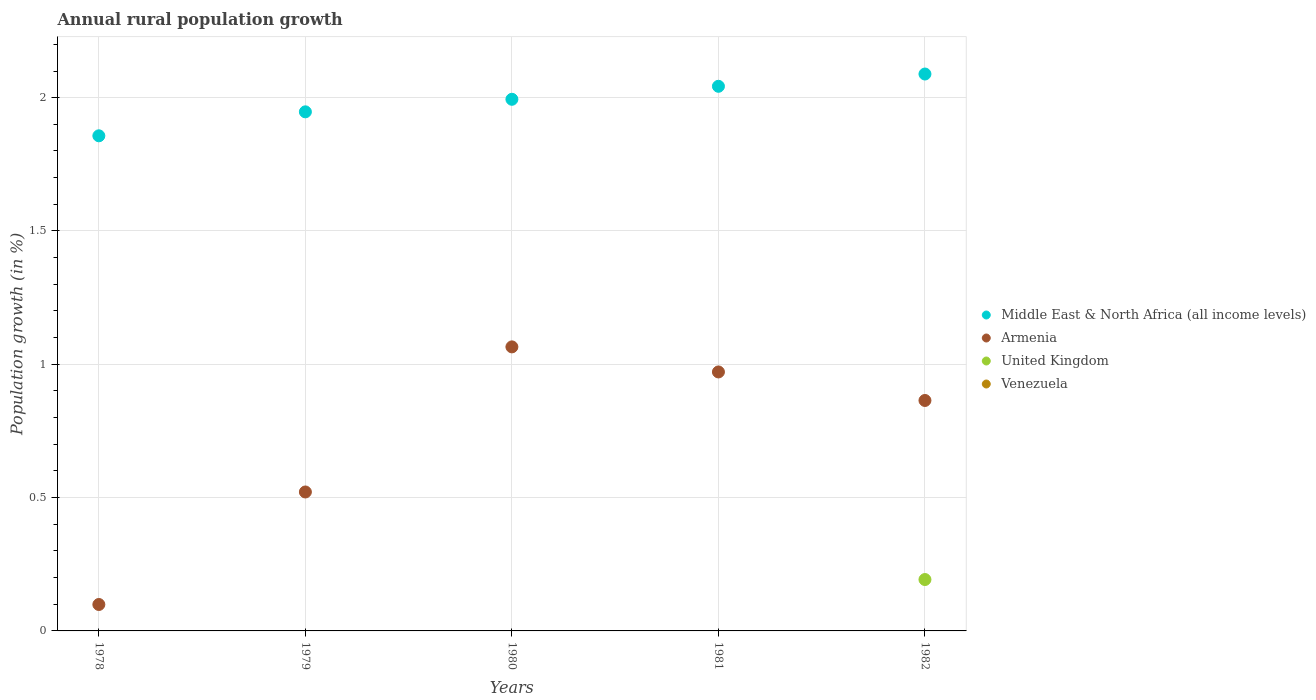How many different coloured dotlines are there?
Your answer should be compact. 3. Is the number of dotlines equal to the number of legend labels?
Provide a succinct answer. No. What is the percentage of rural population growth in United Kingdom in 1978?
Your response must be concise. 0. Across all years, what is the maximum percentage of rural population growth in United Kingdom?
Ensure brevity in your answer.  0.19. Across all years, what is the minimum percentage of rural population growth in Armenia?
Offer a very short reply. 0.1. In which year was the percentage of rural population growth in Armenia maximum?
Provide a short and direct response. 1980. What is the total percentage of rural population growth in Middle East & North Africa (all income levels) in the graph?
Offer a terse response. 9.93. What is the difference between the percentage of rural population growth in Middle East & North Africa (all income levels) in 1978 and that in 1982?
Your answer should be compact. -0.23. What is the difference between the percentage of rural population growth in Middle East & North Africa (all income levels) in 1979 and the percentage of rural population growth in United Kingdom in 1980?
Offer a very short reply. 1.95. What is the average percentage of rural population growth in Middle East & North Africa (all income levels) per year?
Your answer should be compact. 1.99. In the year 1979, what is the difference between the percentage of rural population growth in Middle East & North Africa (all income levels) and percentage of rural population growth in Armenia?
Ensure brevity in your answer.  1.43. What is the ratio of the percentage of rural population growth in Middle East & North Africa (all income levels) in 1980 to that in 1981?
Your answer should be very brief. 0.98. Is the percentage of rural population growth in Middle East & North Africa (all income levels) in 1978 less than that in 1982?
Offer a terse response. Yes. Is the difference between the percentage of rural population growth in Middle East & North Africa (all income levels) in 1979 and 1981 greater than the difference between the percentage of rural population growth in Armenia in 1979 and 1981?
Your response must be concise. Yes. What is the difference between the highest and the second highest percentage of rural population growth in Middle East & North Africa (all income levels)?
Provide a short and direct response. 0.05. Is the sum of the percentage of rural population growth in Armenia in 1978 and 1979 greater than the maximum percentage of rural population growth in Middle East & North Africa (all income levels) across all years?
Offer a very short reply. No. Is it the case that in every year, the sum of the percentage of rural population growth in Venezuela and percentage of rural population growth in Middle East & North Africa (all income levels)  is greater than the percentage of rural population growth in United Kingdom?
Keep it short and to the point. Yes. Does the percentage of rural population growth in Middle East & North Africa (all income levels) monotonically increase over the years?
Make the answer very short. Yes. Is the percentage of rural population growth in Armenia strictly greater than the percentage of rural population growth in Middle East & North Africa (all income levels) over the years?
Your response must be concise. No. Is the percentage of rural population growth in Middle East & North Africa (all income levels) strictly less than the percentage of rural population growth in Venezuela over the years?
Offer a terse response. No. Does the graph contain grids?
Give a very brief answer. Yes. Where does the legend appear in the graph?
Your answer should be very brief. Center right. How are the legend labels stacked?
Your answer should be compact. Vertical. What is the title of the graph?
Ensure brevity in your answer.  Annual rural population growth. Does "Iran" appear as one of the legend labels in the graph?
Provide a succinct answer. No. What is the label or title of the X-axis?
Give a very brief answer. Years. What is the label or title of the Y-axis?
Offer a terse response. Population growth (in %). What is the Population growth (in %) in Middle East & North Africa (all income levels) in 1978?
Keep it short and to the point. 1.86. What is the Population growth (in %) in Armenia in 1978?
Provide a short and direct response. 0.1. What is the Population growth (in %) in United Kingdom in 1978?
Make the answer very short. 0. What is the Population growth (in %) in Venezuela in 1978?
Your response must be concise. 0. What is the Population growth (in %) of Middle East & North Africa (all income levels) in 1979?
Ensure brevity in your answer.  1.95. What is the Population growth (in %) in Armenia in 1979?
Provide a succinct answer. 0.52. What is the Population growth (in %) in United Kingdom in 1979?
Ensure brevity in your answer.  0. What is the Population growth (in %) of Venezuela in 1979?
Ensure brevity in your answer.  0. What is the Population growth (in %) of Middle East & North Africa (all income levels) in 1980?
Provide a succinct answer. 1.99. What is the Population growth (in %) in Armenia in 1980?
Offer a very short reply. 1.07. What is the Population growth (in %) of Middle East & North Africa (all income levels) in 1981?
Provide a succinct answer. 2.04. What is the Population growth (in %) of Armenia in 1981?
Your answer should be compact. 0.97. What is the Population growth (in %) of United Kingdom in 1981?
Your answer should be very brief. 0. What is the Population growth (in %) in Venezuela in 1981?
Your answer should be compact. 0. What is the Population growth (in %) of Middle East & North Africa (all income levels) in 1982?
Provide a short and direct response. 2.09. What is the Population growth (in %) in Armenia in 1982?
Your answer should be compact. 0.86. What is the Population growth (in %) in United Kingdom in 1982?
Give a very brief answer. 0.19. What is the Population growth (in %) in Venezuela in 1982?
Keep it short and to the point. 0. Across all years, what is the maximum Population growth (in %) of Middle East & North Africa (all income levels)?
Offer a very short reply. 2.09. Across all years, what is the maximum Population growth (in %) of Armenia?
Give a very brief answer. 1.07. Across all years, what is the maximum Population growth (in %) of United Kingdom?
Your response must be concise. 0.19. Across all years, what is the minimum Population growth (in %) in Middle East & North Africa (all income levels)?
Your answer should be compact. 1.86. Across all years, what is the minimum Population growth (in %) of Armenia?
Your answer should be compact. 0.1. What is the total Population growth (in %) of Middle East & North Africa (all income levels) in the graph?
Your answer should be very brief. 9.93. What is the total Population growth (in %) in Armenia in the graph?
Your answer should be compact. 3.52. What is the total Population growth (in %) in United Kingdom in the graph?
Offer a very short reply. 0.19. What is the total Population growth (in %) in Venezuela in the graph?
Make the answer very short. 0. What is the difference between the Population growth (in %) in Middle East & North Africa (all income levels) in 1978 and that in 1979?
Offer a very short reply. -0.09. What is the difference between the Population growth (in %) in Armenia in 1978 and that in 1979?
Your answer should be compact. -0.42. What is the difference between the Population growth (in %) of Middle East & North Africa (all income levels) in 1978 and that in 1980?
Ensure brevity in your answer.  -0.14. What is the difference between the Population growth (in %) of Armenia in 1978 and that in 1980?
Your answer should be compact. -0.97. What is the difference between the Population growth (in %) in Middle East & North Africa (all income levels) in 1978 and that in 1981?
Provide a short and direct response. -0.19. What is the difference between the Population growth (in %) of Armenia in 1978 and that in 1981?
Ensure brevity in your answer.  -0.87. What is the difference between the Population growth (in %) in Middle East & North Africa (all income levels) in 1978 and that in 1982?
Offer a very short reply. -0.23. What is the difference between the Population growth (in %) in Armenia in 1978 and that in 1982?
Provide a succinct answer. -0.77. What is the difference between the Population growth (in %) of Middle East & North Africa (all income levels) in 1979 and that in 1980?
Make the answer very short. -0.05. What is the difference between the Population growth (in %) in Armenia in 1979 and that in 1980?
Keep it short and to the point. -0.54. What is the difference between the Population growth (in %) of Middle East & North Africa (all income levels) in 1979 and that in 1981?
Ensure brevity in your answer.  -0.1. What is the difference between the Population growth (in %) in Armenia in 1979 and that in 1981?
Ensure brevity in your answer.  -0.45. What is the difference between the Population growth (in %) in Middle East & North Africa (all income levels) in 1979 and that in 1982?
Ensure brevity in your answer.  -0.14. What is the difference between the Population growth (in %) in Armenia in 1979 and that in 1982?
Your answer should be compact. -0.34. What is the difference between the Population growth (in %) of Middle East & North Africa (all income levels) in 1980 and that in 1981?
Give a very brief answer. -0.05. What is the difference between the Population growth (in %) of Armenia in 1980 and that in 1981?
Your answer should be compact. 0.09. What is the difference between the Population growth (in %) of Middle East & North Africa (all income levels) in 1980 and that in 1982?
Provide a short and direct response. -0.09. What is the difference between the Population growth (in %) of Armenia in 1980 and that in 1982?
Your answer should be compact. 0.2. What is the difference between the Population growth (in %) of Middle East & North Africa (all income levels) in 1981 and that in 1982?
Provide a succinct answer. -0.05. What is the difference between the Population growth (in %) of Armenia in 1981 and that in 1982?
Provide a short and direct response. 0.11. What is the difference between the Population growth (in %) in Middle East & North Africa (all income levels) in 1978 and the Population growth (in %) in Armenia in 1979?
Your response must be concise. 1.34. What is the difference between the Population growth (in %) of Middle East & North Africa (all income levels) in 1978 and the Population growth (in %) of Armenia in 1980?
Offer a very short reply. 0.79. What is the difference between the Population growth (in %) in Middle East & North Africa (all income levels) in 1978 and the Population growth (in %) in Armenia in 1981?
Your answer should be very brief. 0.89. What is the difference between the Population growth (in %) of Middle East & North Africa (all income levels) in 1978 and the Population growth (in %) of Armenia in 1982?
Offer a very short reply. 0.99. What is the difference between the Population growth (in %) of Middle East & North Africa (all income levels) in 1978 and the Population growth (in %) of United Kingdom in 1982?
Offer a terse response. 1.66. What is the difference between the Population growth (in %) of Armenia in 1978 and the Population growth (in %) of United Kingdom in 1982?
Keep it short and to the point. -0.09. What is the difference between the Population growth (in %) of Middle East & North Africa (all income levels) in 1979 and the Population growth (in %) of Armenia in 1980?
Provide a short and direct response. 0.88. What is the difference between the Population growth (in %) of Middle East & North Africa (all income levels) in 1979 and the Population growth (in %) of Armenia in 1981?
Offer a very short reply. 0.98. What is the difference between the Population growth (in %) in Middle East & North Africa (all income levels) in 1979 and the Population growth (in %) in Armenia in 1982?
Ensure brevity in your answer.  1.08. What is the difference between the Population growth (in %) in Middle East & North Africa (all income levels) in 1979 and the Population growth (in %) in United Kingdom in 1982?
Your response must be concise. 1.75. What is the difference between the Population growth (in %) in Armenia in 1979 and the Population growth (in %) in United Kingdom in 1982?
Your answer should be compact. 0.33. What is the difference between the Population growth (in %) in Middle East & North Africa (all income levels) in 1980 and the Population growth (in %) in Armenia in 1981?
Offer a very short reply. 1.02. What is the difference between the Population growth (in %) of Middle East & North Africa (all income levels) in 1980 and the Population growth (in %) of Armenia in 1982?
Your response must be concise. 1.13. What is the difference between the Population growth (in %) of Middle East & North Africa (all income levels) in 1980 and the Population growth (in %) of United Kingdom in 1982?
Keep it short and to the point. 1.8. What is the difference between the Population growth (in %) in Armenia in 1980 and the Population growth (in %) in United Kingdom in 1982?
Provide a short and direct response. 0.87. What is the difference between the Population growth (in %) in Middle East & North Africa (all income levels) in 1981 and the Population growth (in %) in Armenia in 1982?
Provide a short and direct response. 1.18. What is the difference between the Population growth (in %) in Middle East & North Africa (all income levels) in 1981 and the Population growth (in %) in United Kingdom in 1982?
Provide a short and direct response. 1.85. What is the difference between the Population growth (in %) of Armenia in 1981 and the Population growth (in %) of United Kingdom in 1982?
Offer a very short reply. 0.78. What is the average Population growth (in %) in Middle East & North Africa (all income levels) per year?
Keep it short and to the point. 1.99. What is the average Population growth (in %) of Armenia per year?
Your answer should be compact. 0.7. What is the average Population growth (in %) of United Kingdom per year?
Make the answer very short. 0.04. What is the average Population growth (in %) of Venezuela per year?
Ensure brevity in your answer.  0. In the year 1978, what is the difference between the Population growth (in %) of Middle East & North Africa (all income levels) and Population growth (in %) of Armenia?
Your answer should be very brief. 1.76. In the year 1979, what is the difference between the Population growth (in %) of Middle East & North Africa (all income levels) and Population growth (in %) of Armenia?
Keep it short and to the point. 1.43. In the year 1980, what is the difference between the Population growth (in %) in Middle East & North Africa (all income levels) and Population growth (in %) in Armenia?
Ensure brevity in your answer.  0.93. In the year 1981, what is the difference between the Population growth (in %) in Middle East & North Africa (all income levels) and Population growth (in %) in Armenia?
Offer a very short reply. 1.07. In the year 1982, what is the difference between the Population growth (in %) of Middle East & North Africa (all income levels) and Population growth (in %) of Armenia?
Provide a short and direct response. 1.22. In the year 1982, what is the difference between the Population growth (in %) in Middle East & North Africa (all income levels) and Population growth (in %) in United Kingdom?
Give a very brief answer. 1.9. In the year 1982, what is the difference between the Population growth (in %) in Armenia and Population growth (in %) in United Kingdom?
Provide a succinct answer. 0.67. What is the ratio of the Population growth (in %) in Middle East & North Africa (all income levels) in 1978 to that in 1979?
Offer a terse response. 0.95. What is the ratio of the Population growth (in %) of Armenia in 1978 to that in 1979?
Offer a terse response. 0.19. What is the ratio of the Population growth (in %) in Middle East & North Africa (all income levels) in 1978 to that in 1980?
Your response must be concise. 0.93. What is the ratio of the Population growth (in %) of Armenia in 1978 to that in 1980?
Make the answer very short. 0.09. What is the ratio of the Population growth (in %) of Armenia in 1978 to that in 1981?
Offer a terse response. 0.1. What is the ratio of the Population growth (in %) in Middle East & North Africa (all income levels) in 1978 to that in 1982?
Provide a succinct answer. 0.89. What is the ratio of the Population growth (in %) of Armenia in 1978 to that in 1982?
Your answer should be compact. 0.11. What is the ratio of the Population growth (in %) in Middle East & North Africa (all income levels) in 1979 to that in 1980?
Your response must be concise. 0.98. What is the ratio of the Population growth (in %) of Armenia in 1979 to that in 1980?
Your answer should be compact. 0.49. What is the ratio of the Population growth (in %) of Middle East & North Africa (all income levels) in 1979 to that in 1981?
Give a very brief answer. 0.95. What is the ratio of the Population growth (in %) in Armenia in 1979 to that in 1981?
Your answer should be very brief. 0.54. What is the ratio of the Population growth (in %) of Middle East & North Africa (all income levels) in 1979 to that in 1982?
Your response must be concise. 0.93. What is the ratio of the Population growth (in %) in Armenia in 1979 to that in 1982?
Ensure brevity in your answer.  0.6. What is the ratio of the Population growth (in %) in Middle East & North Africa (all income levels) in 1980 to that in 1981?
Provide a short and direct response. 0.98. What is the ratio of the Population growth (in %) in Armenia in 1980 to that in 1981?
Give a very brief answer. 1.1. What is the ratio of the Population growth (in %) of Middle East & North Africa (all income levels) in 1980 to that in 1982?
Ensure brevity in your answer.  0.95. What is the ratio of the Population growth (in %) in Armenia in 1980 to that in 1982?
Your answer should be compact. 1.23. What is the ratio of the Population growth (in %) in Middle East & North Africa (all income levels) in 1981 to that in 1982?
Keep it short and to the point. 0.98. What is the ratio of the Population growth (in %) in Armenia in 1981 to that in 1982?
Provide a succinct answer. 1.12. What is the difference between the highest and the second highest Population growth (in %) of Middle East & North Africa (all income levels)?
Offer a very short reply. 0.05. What is the difference between the highest and the second highest Population growth (in %) in Armenia?
Make the answer very short. 0.09. What is the difference between the highest and the lowest Population growth (in %) in Middle East & North Africa (all income levels)?
Provide a succinct answer. 0.23. What is the difference between the highest and the lowest Population growth (in %) in Armenia?
Ensure brevity in your answer.  0.97. What is the difference between the highest and the lowest Population growth (in %) in United Kingdom?
Offer a very short reply. 0.19. 